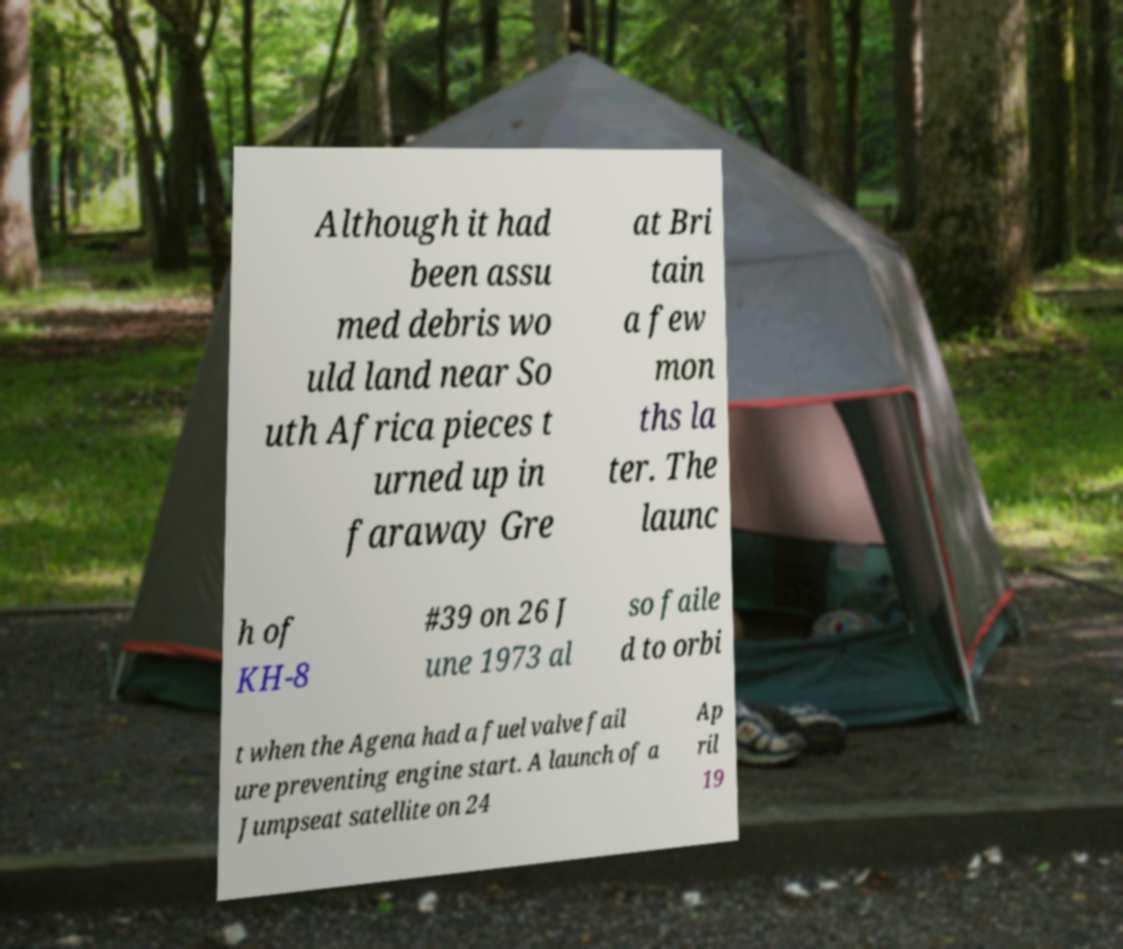There's text embedded in this image that I need extracted. Can you transcribe it verbatim? Although it had been assu med debris wo uld land near So uth Africa pieces t urned up in faraway Gre at Bri tain a few mon ths la ter. The launc h of KH-8 #39 on 26 J une 1973 al so faile d to orbi t when the Agena had a fuel valve fail ure preventing engine start. A launch of a Jumpseat satellite on 24 Ap ril 19 